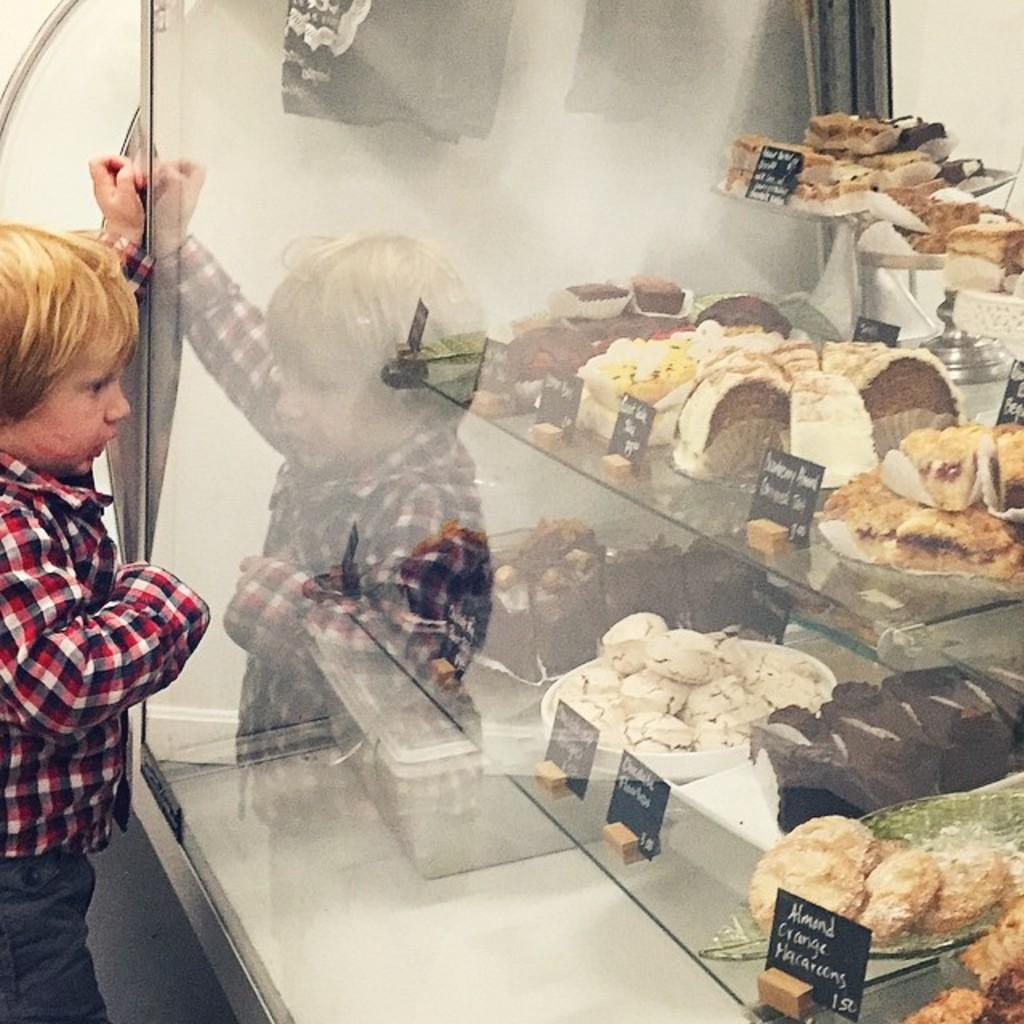What is located on the left side of the image? There is a boy standing on the left side of the image. What is in front of the boy? There is a shelf in front of the boy. What can be seen on the shelf? Desserts are placed on the shelf. Reasoning: Let's think step by step by step in order to produce the conversation. We start by identifying the main subject in the image, which is the boy. Then, we describe the object in front of him, which is a shelf. Finally, we mention the items that are on the shelf, which are desserts. Each question is designed to elicit a specific detail about the image that is known from the provided facts. Absurd Question/Answer: Can you see any insects crawling on the desserts in the image? There are no insects visible in the image, so it cannot be determined if any are crawling on the desserts. What type of sack is being used to store the desserts on the shelf? There is no sack present in the image; the desserts are placed directly on the shelf. --- Facts: 1. There is a group of people in the image. 2. The people are wearing hats. 3. The people are holding umbrellas. 4. The background of the image is a cityscape. Absurd Topics: fish, bicycle, mountain Conversation: What can be seen in the image? There is a group of people in the image. What are the people wearing? The people are wearing hats. What are the people holding? The people are holding umbrellas. What is visible in the background of the image? The background of the image is a cityscape. Reasoning: Let's think step by step in order to produce the conversation. We start by identifying the main subject in the image, which is the group of people. Then, we describe the clothing and accessories they are wearing, which are hats and umbrellas. Finally, we mention the background of the image, which is a cityscape. Each question is designed to elicit a specific detail about the image that is known from the provided facts. Abs 